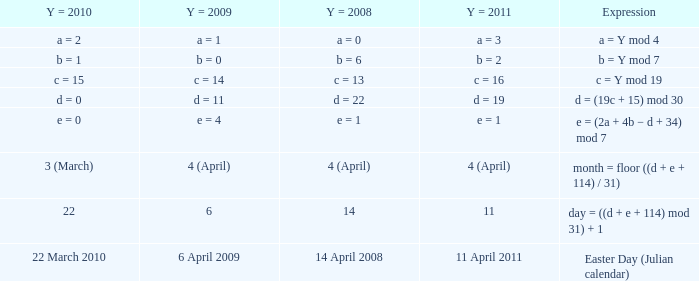What is the y = 2008 when y = 2011 is a = 3? A = 0. 